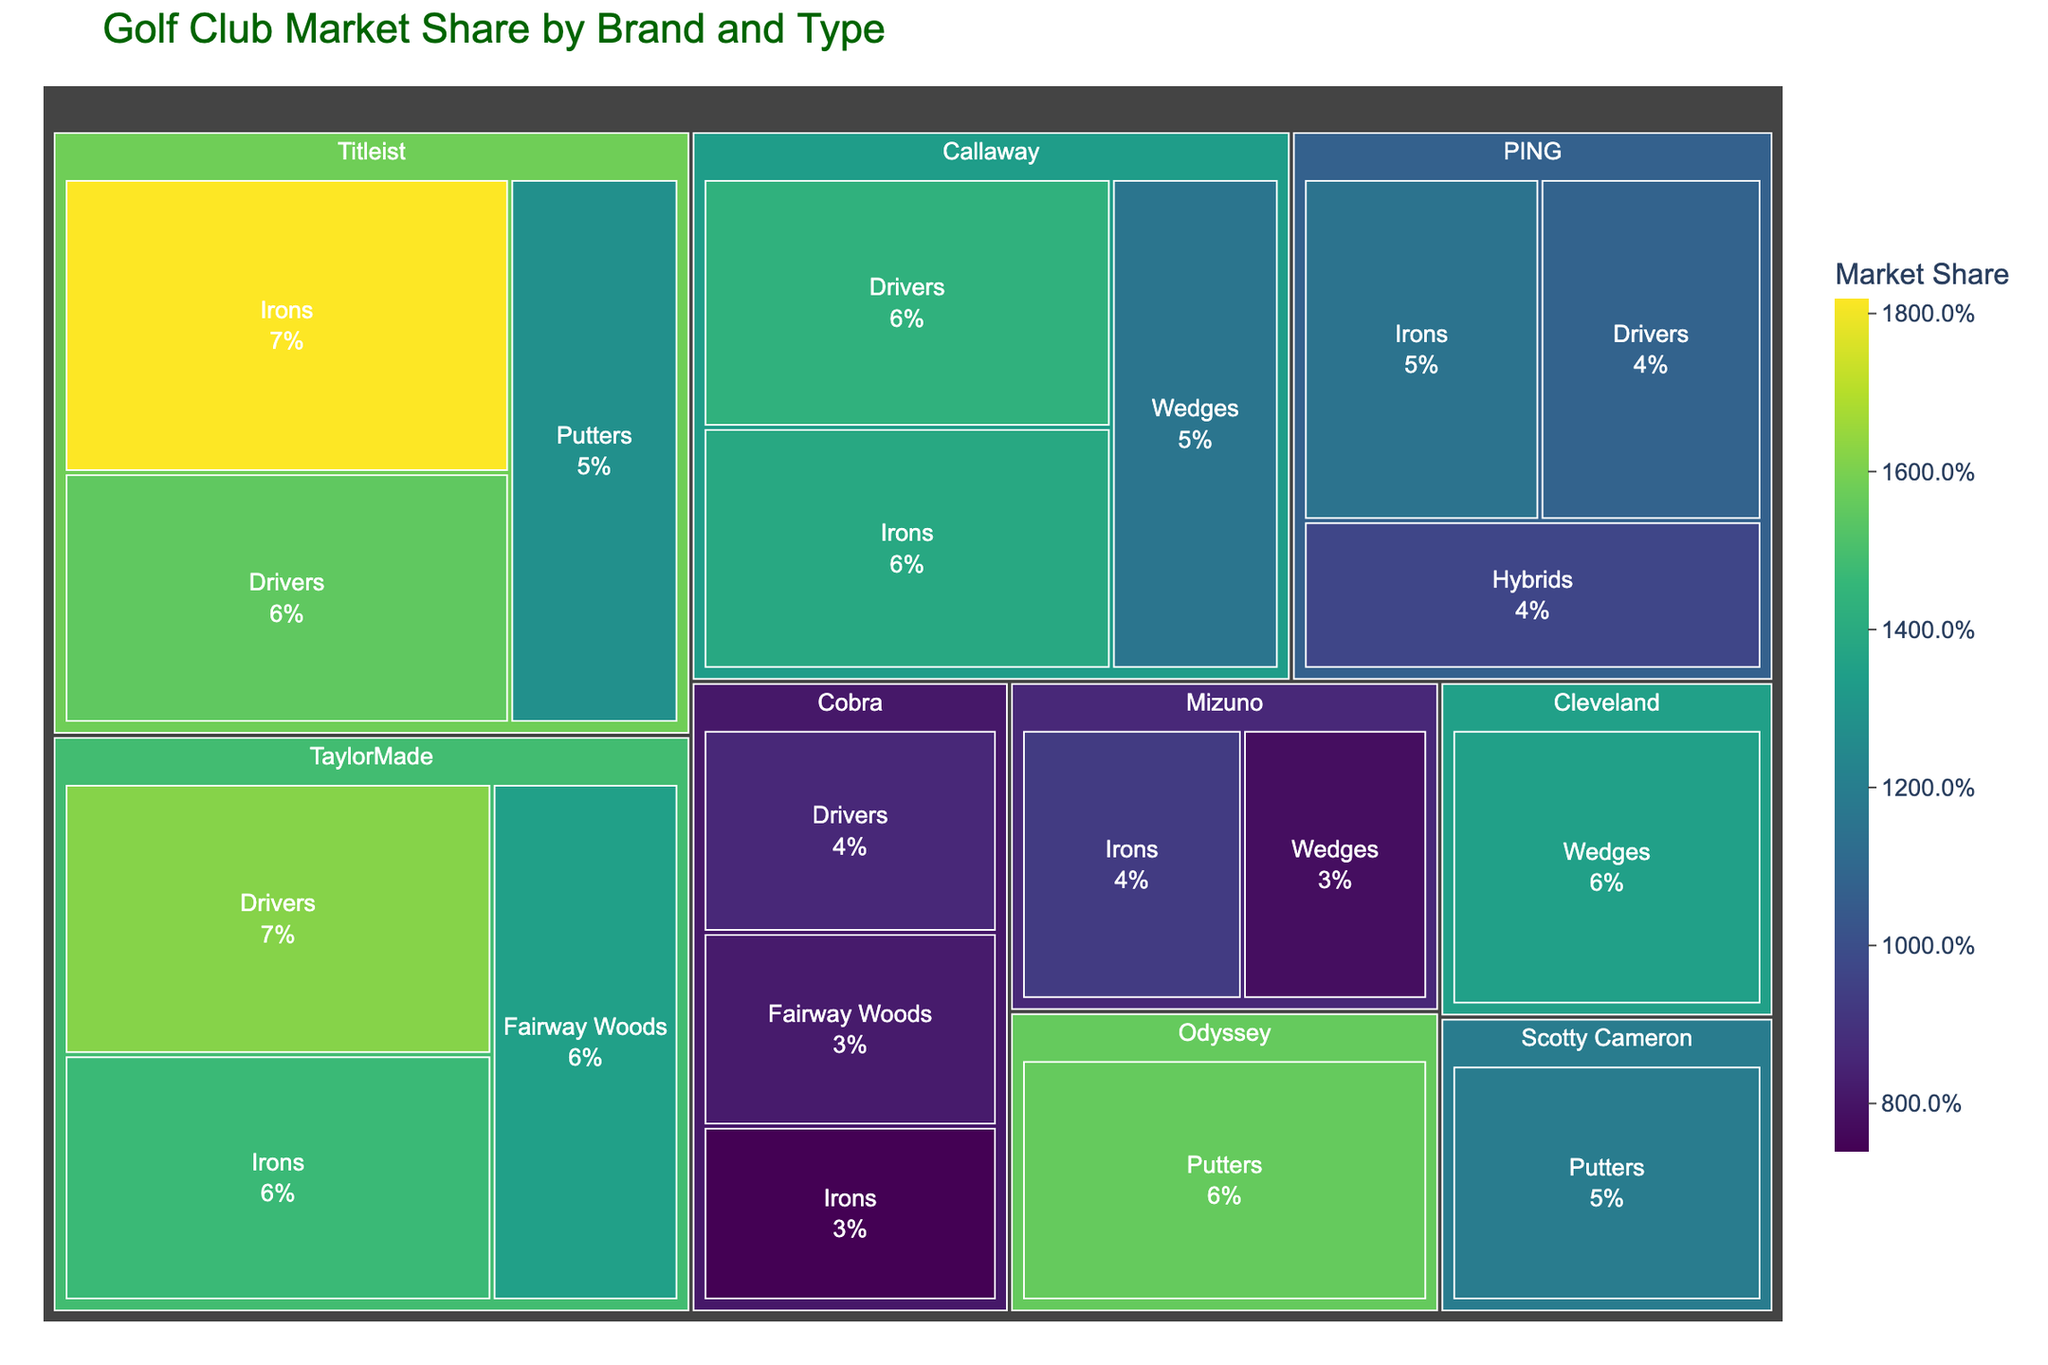Which brand has the largest market share for putters? The Treemap shows different brands and their market share by type. By looking specifically at putters and comparing the market share, Odyssey has the largest share for putters with 15.6%.
Answer: Odyssey Which type of golf club does TaylorMade have the highest market share in? TaylorMade's highest market share among its club types can be found by comparing the market share percentages. The highest is for Drivers at 16.2%.
Answer: Drivers What is the total market share for all types of clubs by Titleist? Adding together Titleist's market share from Drivers (15.5%), Irons (18.2%), and Putters (12.8%) results in a total of 46.5%.
Answer: 46.5% Who has a higher market share in drivers, TaylorMade or Callaway? By comparing the market share for drivers from the Treemap, TaylorMade has 16.2%, while Callaway has 14.3% for drivers.
Answer: TaylorMade Which brand has the lowest market share for irons? Looking at the market share for irons across all brands, Cobra has the lowest with 7.4%.
Answer: Cobra Of the brands that sell wedges, which one has the smallest market share? Among the brands selling wedges—Callaway, Mizuno, and Cleveland—Mizuno has the smallest market share with 7.8%.
Answer: Mizuno What is the combined market share for putters from Odyssey and Scotty Cameron? Adding the market shares for putters from Odyssey (15.6%) and Scotty Cameron (11.9%) results in a total of 27.5%.
Answer: 27.5% Does PING have a higher market share in hybrids or drivers? By comparing PING's market share, hybrids have 9.7%, while drivers have 10.8%. PING has a higher share in drivers.
Answer: Drivers Among Titleist, Callaway, and TaylorMade, which has the highest market share in irons? Comparing the market share for irons among the three, Titleist has 18.2%, Callaway has 13.9%, and TaylorMade has 14.7%. Titleist has the highest market share.
Answer: Titleist What is the difference in market share between Cleveland and Titleist for wedges? Cleveland has a market share of 13.5% for wedges, while Titleist does not sell wedges. Therefore, Cleveland's value remains the market share for wedges.
Answer: 13.5% 